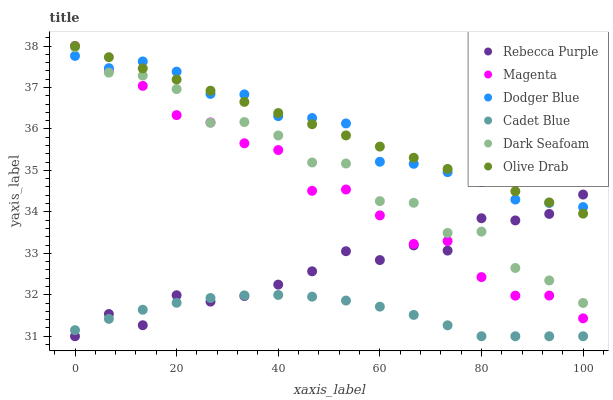Does Cadet Blue have the minimum area under the curve?
Answer yes or no. Yes. Does Olive Drab have the maximum area under the curve?
Answer yes or no. Yes. Does Dark Seafoam have the minimum area under the curve?
Answer yes or no. No. Does Dark Seafoam have the maximum area under the curve?
Answer yes or no. No. Is Olive Drab the smoothest?
Answer yes or no. Yes. Is Dark Seafoam the roughest?
Answer yes or no. Yes. Is Dodger Blue the smoothest?
Answer yes or no. No. Is Dodger Blue the roughest?
Answer yes or no. No. Does Cadet Blue have the lowest value?
Answer yes or no. Yes. Does Dark Seafoam have the lowest value?
Answer yes or no. No. Does Olive Drab have the highest value?
Answer yes or no. Yes. Does Dark Seafoam have the highest value?
Answer yes or no. No. Is Cadet Blue less than Dark Seafoam?
Answer yes or no. Yes. Is Dark Seafoam greater than Cadet Blue?
Answer yes or no. Yes. Does Rebecca Purple intersect Dark Seafoam?
Answer yes or no. Yes. Is Rebecca Purple less than Dark Seafoam?
Answer yes or no. No. Is Rebecca Purple greater than Dark Seafoam?
Answer yes or no. No. Does Cadet Blue intersect Dark Seafoam?
Answer yes or no. No. 